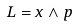Convert formula to latex. <formula><loc_0><loc_0><loc_500><loc_500>L = x \wedge p</formula> 